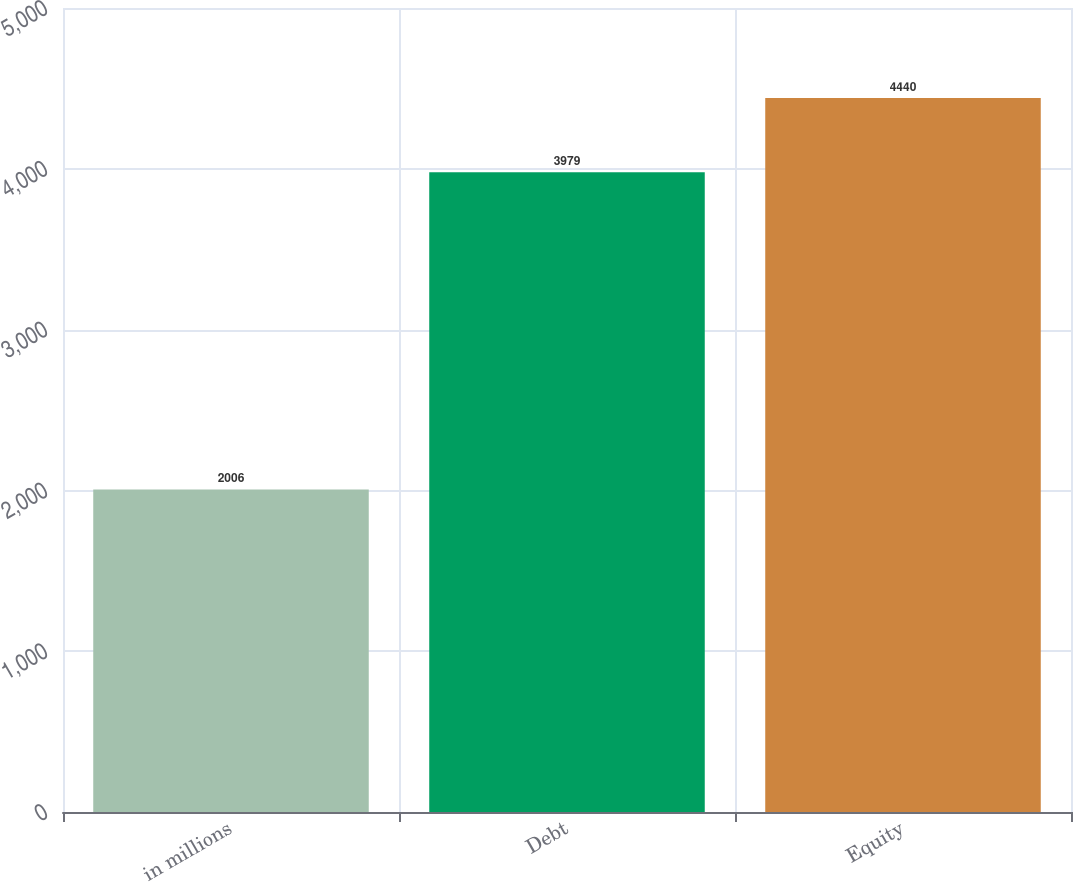Convert chart to OTSL. <chart><loc_0><loc_0><loc_500><loc_500><bar_chart><fcel>in millions<fcel>Debt<fcel>Equity<nl><fcel>2006<fcel>3979<fcel>4440<nl></chart> 